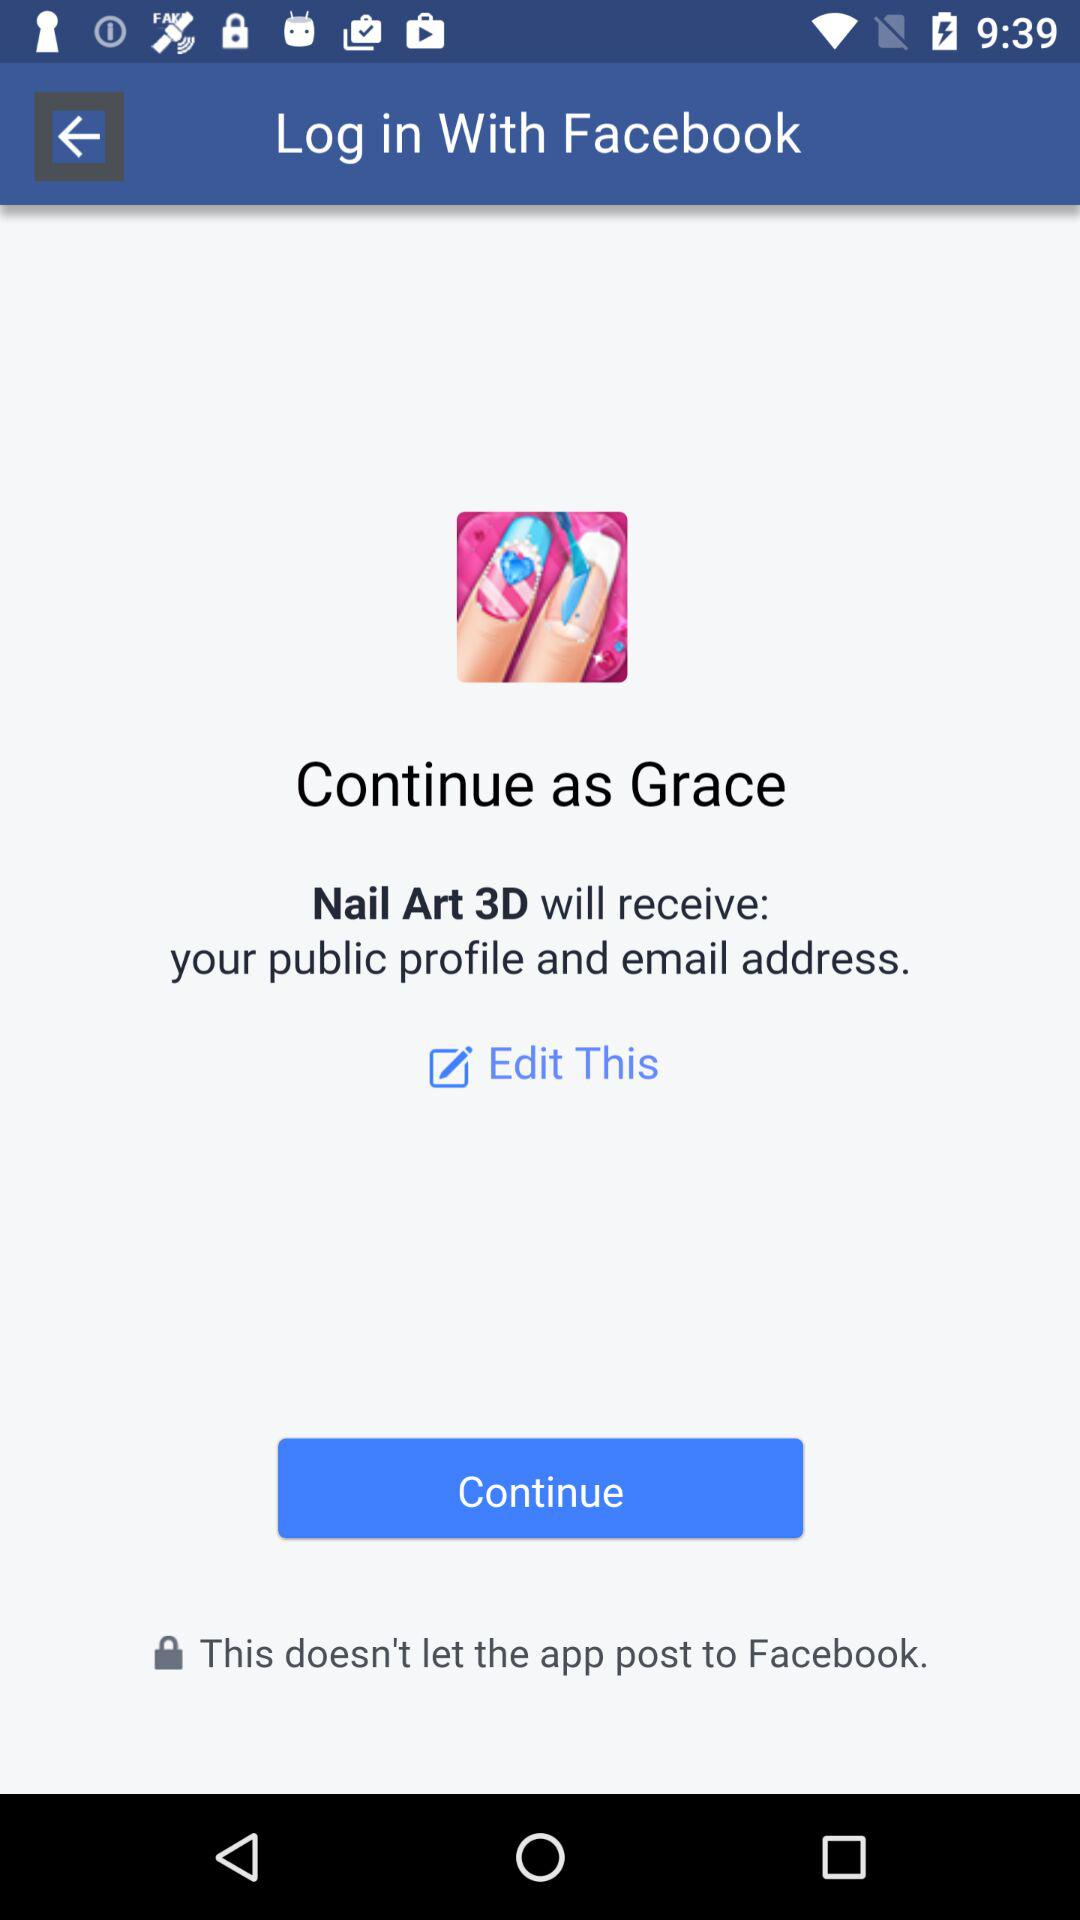Through what application can we log in? You can log in through "Facebook". 